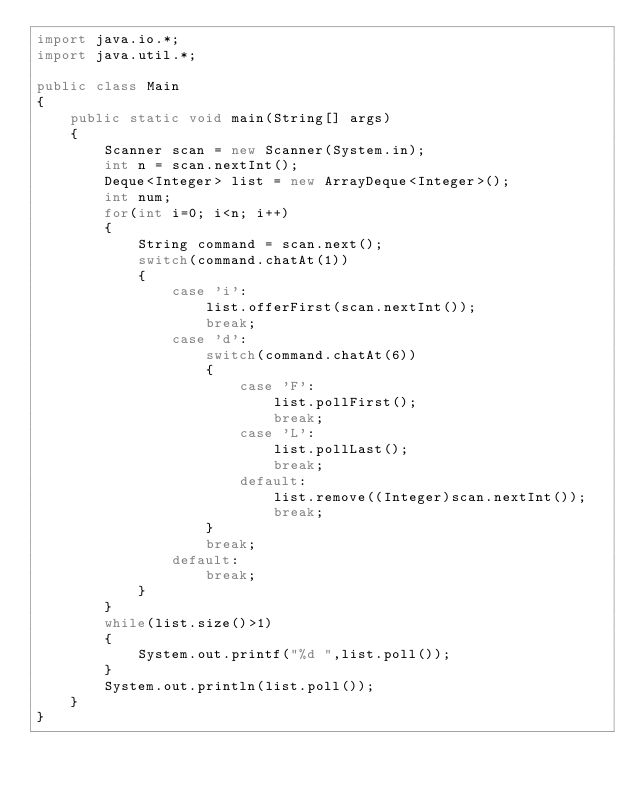Convert code to text. <code><loc_0><loc_0><loc_500><loc_500><_Java_>import java.io.*;
import java.util.*;

public class Main
{
    public static void main(String[] args)
    {
        Scanner scan = new Scanner(System.in);
        int n = scan.nextInt();
        Deque<Integer> list = new ArrayDeque<Integer>();
        int num;
        for(int i=0; i<n; i++)
        {
            String command = scan.next();
            switch(command.chatAt(1))
            {
                case 'i':
                    list.offerFirst(scan.nextInt());
                    break;
                case 'd':
                    switch(command.chatAt(6))
                    {
                        case 'F':
                            list.pollFirst();
                            break;
                        case 'L':
                            list.pollLast();
                            break;
                        default:
                            list.remove((Integer)scan.nextInt());
                            break;
                    }
                    break;
                default:
                    break;
            }
        }
        while(list.size()>1)
        {
            System.out.printf("%d ",list.poll());
        }
        System.out.println(list.poll());
    }
}</code> 